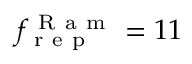Convert formula to latex. <formula><loc_0><loc_0><loc_500><loc_500>f _ { r e p } ^ { R a m } = 1 1</formula> 